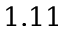Convert formula to latex. <formula><loc_0><loc_0><loc_500><loc_500>1 . 1 1</formula> 